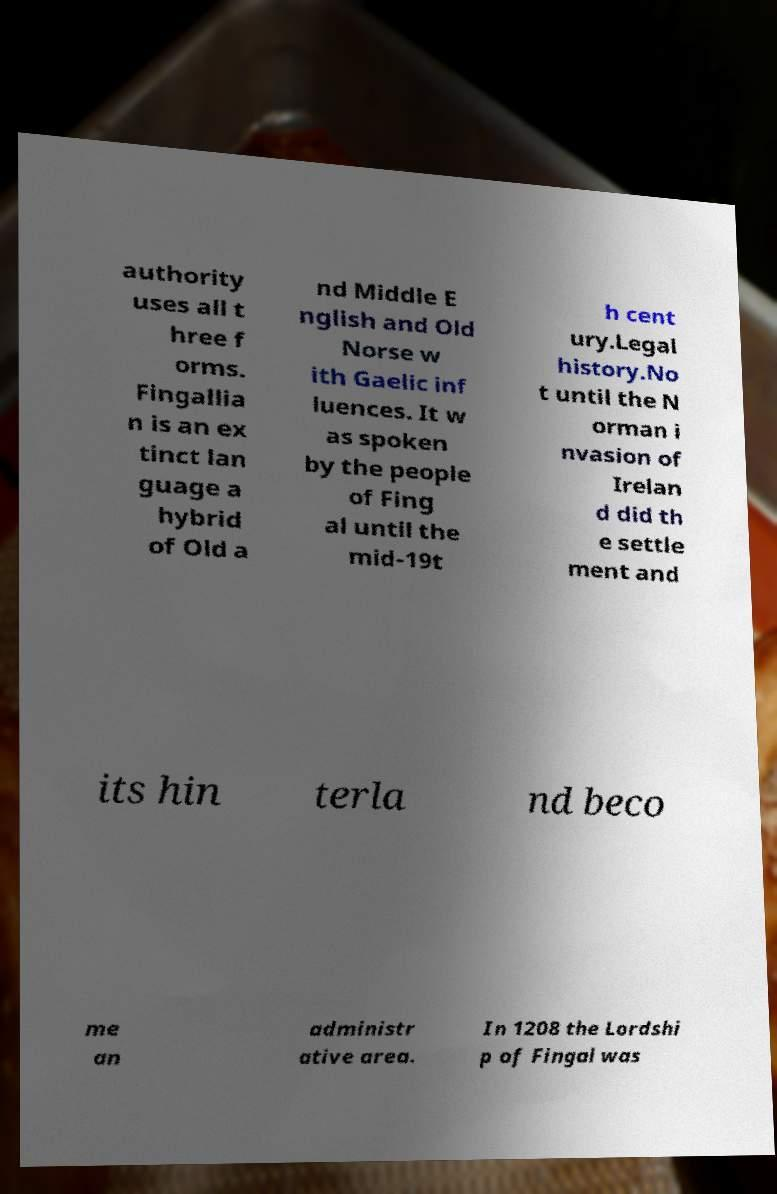Could you extract and type out the text from this image? authority uses all t hree f orms. Fingallia n is an ex tinct lan guage a hybrid of Old a nd Middle E nglish and Old Norse w ith Gaelic inf luences. It w as spoken by the people of Fing al until the mid-19t h cent ury.Legal history.No t until the N orman i nvasion of Irelan d did th e settle ment and its hin terla nd beco me an administr ative area. In 1208 the Lordshi p of Fingal was 